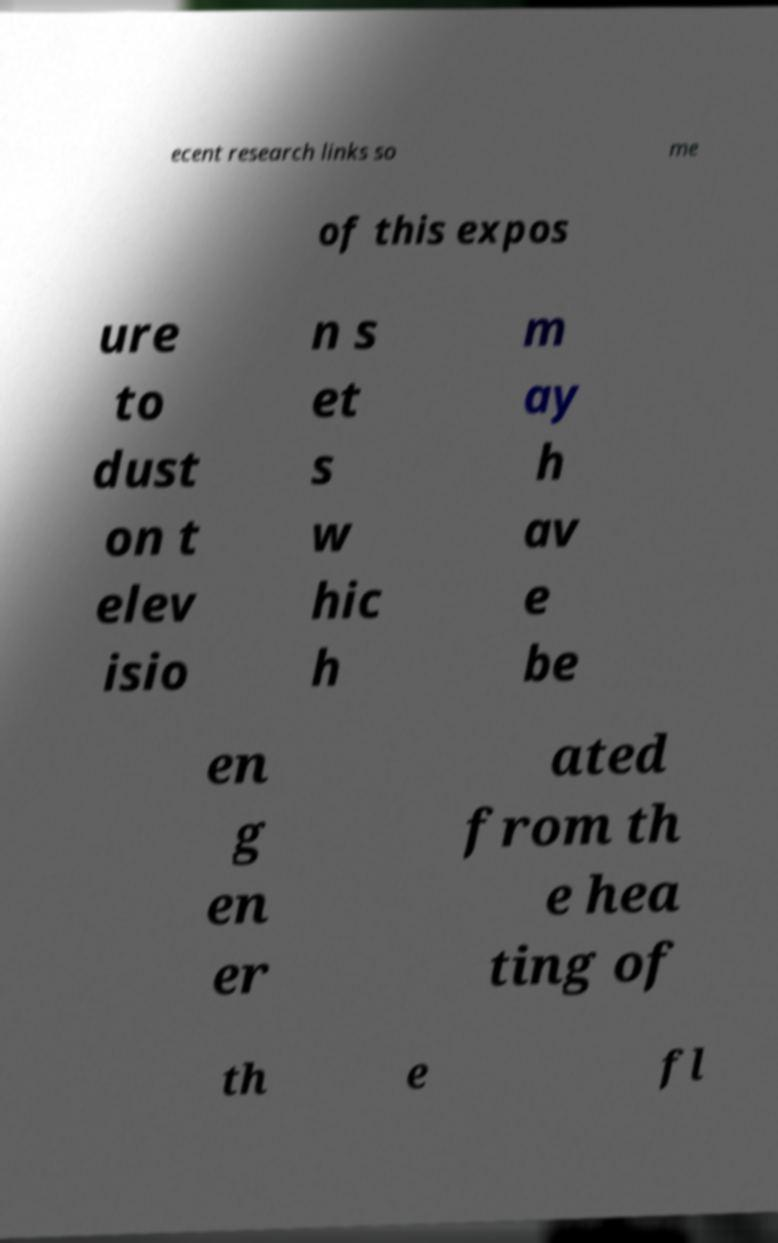Could you assist in decoding the text presented in this image and type it out clearly? ecent research links so me of this expos ure to dust on t elev isio n s et s w hic h m ay h av e be en g en er ated from th e hea ting of th e fl 